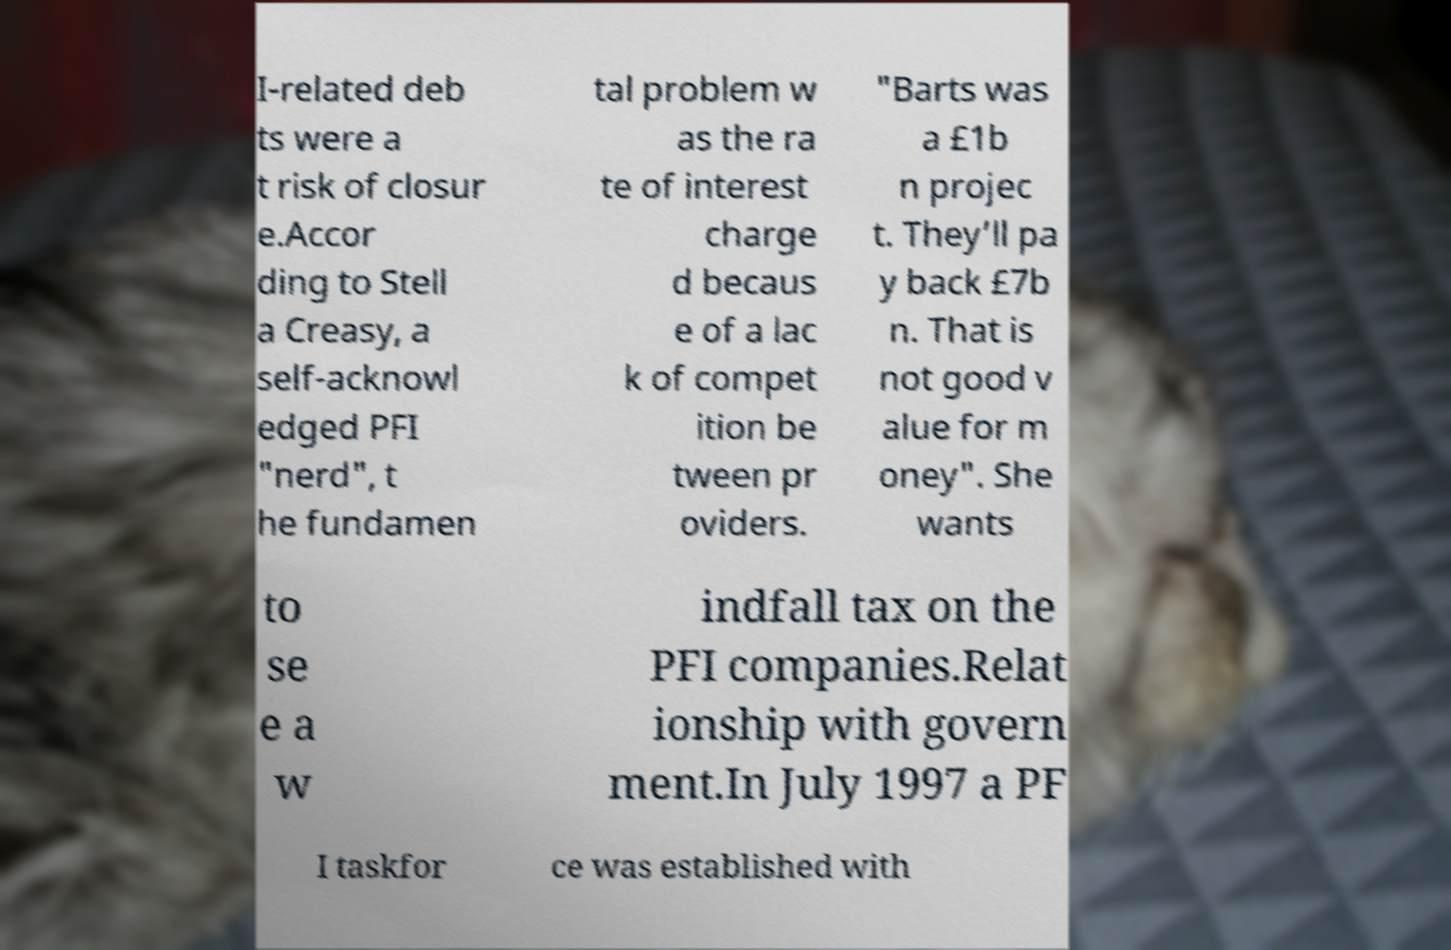What messages or text are displayed in this image? I need them in a readable, typed format. I-related deb ts were a t risk of closur e.Accor ding to Stell a Creasy, a self-acknowl edged PFI "nerd", t he fundamen tal problem w as the ra te of interest charge d becaus e of a lac k of compet ition be tween pr oviders. "Barts was a £1b n projec t. They’ll pa y back £7b n. That is not good v alue for m oney". She wants to se e a w indfall tax on the PFI companies.Relat ionship with govern ment.In July 1997 a PF I taskfor ce was established with 